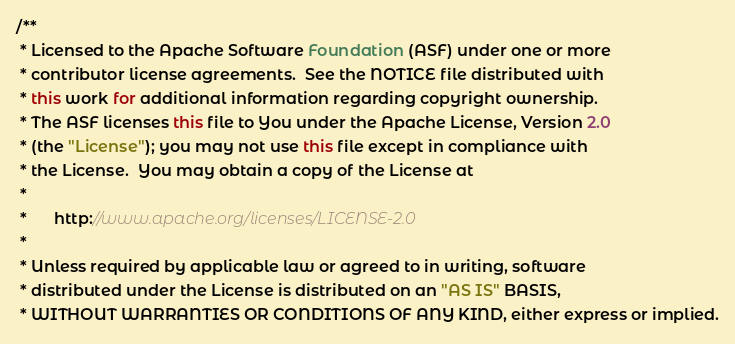<code> <loc_0><loc_0><loc_500><loc_500><_Java_>/**
 * Licensed to the Apache Software Foundation (ASF) under one or more
 * contributor license agreements.  See the NOTICE file distributed with
 * this work for additional information regarding copyright ownership.
 * The ASF licenses this file to You under the Apache License, Version 2.0
 * (the "License"); you may not use this file except in compliance with
 * the License.  You may obtain a copy of the License at
 *
 *      http://www.apache.org/licenses/LICENSE-2.0
 *
 * Unless required by applicable law or agreed to in writing, software
 * distributed under the License is distributed on an "AS IS" BASIS,
 * WITHOUT WARRANTIES OR CONDITIONS OF ANY KIND, either express or implied.</code> 